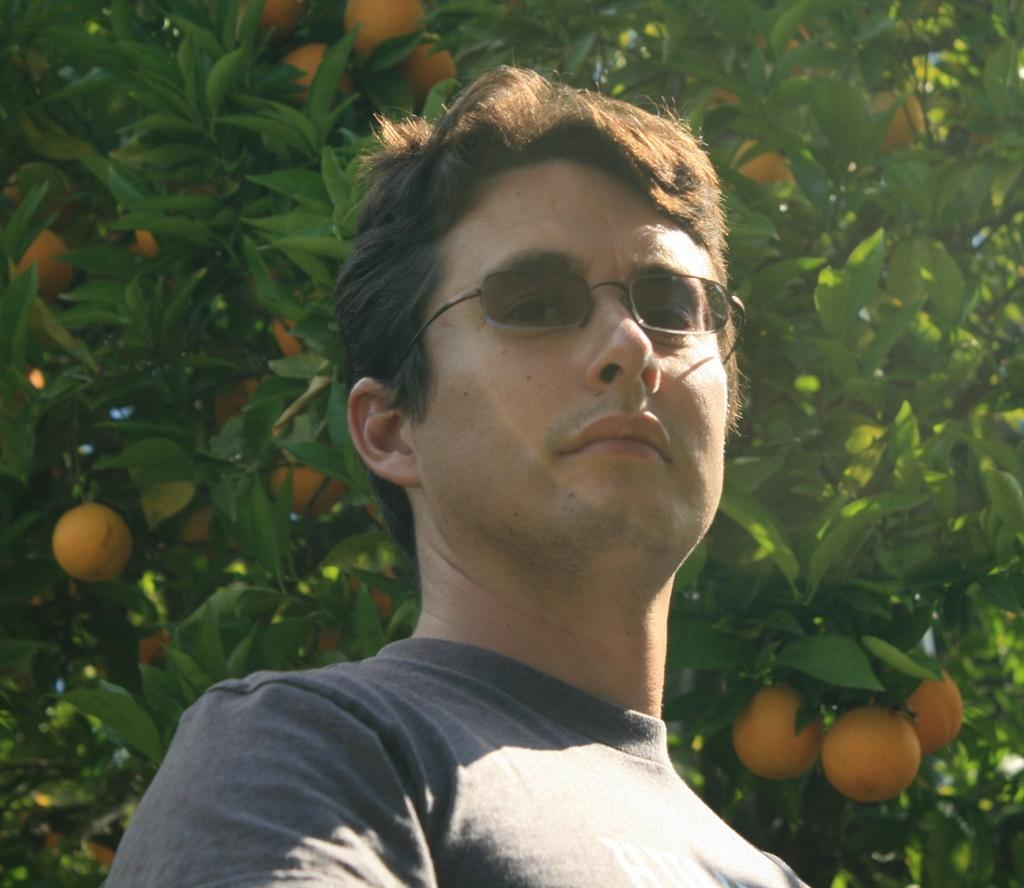Who is present in the image? There is a man in the picture. What is the man wearing on his upper body? The man is wearing a T-shirt. What type of eyewear is the man wearing? The man is wearing shades. What can be seen in the background of the picture? There is a tree in the background of the picture. What is the color or appearance of the tree's leaves or flowers? The tree has yellow color things (possibly leaves or flowers). How many houses can be seen in the image? There are no houses visible in the image; it only features a man and a tree in the background. What type of parent is the man in the image? There is no information about the man's parental status in the image. 